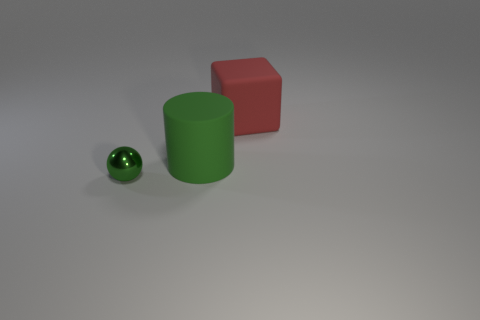What is the size of the cylinder that is made of the same material as the red thing?
Offer a very short reply. Large. How many green metal things are the same size as the green cylinder?
Give a very brief answer. 0. What size is the rubber cylinder that is the same color as the shiny thing?
Provide a succinct answer. Large. What is the color of the thing right of the green object right of the metal sphere?
Provide a short and direct response. Red. Is there a small metallic block of the same color as the rubber cube?
Your answer should be very brief. No. What is the color of the other matte thing that is the same size as the red rubber thing?
Your answer should be compact. Green. Do the big object right of the big green matte thing and the green sphere have the same material?
Provide a short and direct response. No. Is there a big block left of the tiny green ball that is in front of the big matte thing that is left of the big red rubber cube?
Offer a very short reply. No. There is a green thing behind the tiny green metal thing; is it the same shape as the red object?
Provide a succinct answer. No. There is a rubber thing to the right of the large thing that is in front of the red cube; what shape is it?
Your answer should be compact. Cube. 